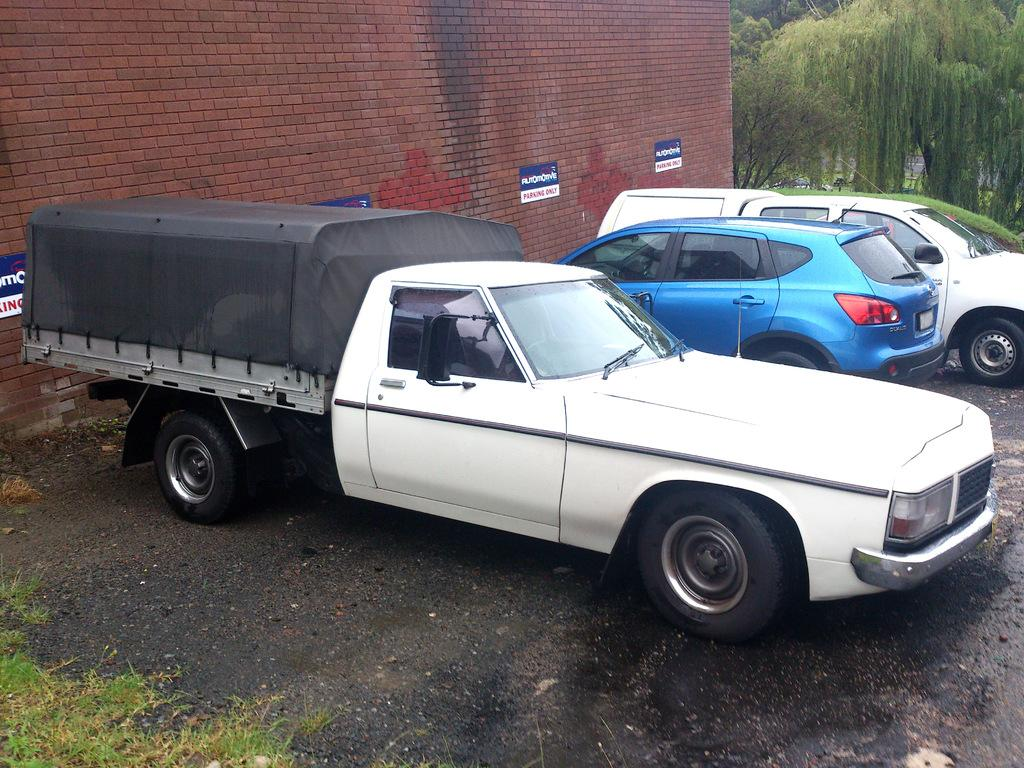What types of objects are present in the image? There are vehicles in the image. Can you describe the appearance of the vehicles? The vehicles are in different colors. What can be seen in the background of the image? There is a wall, banners, trees, grass, and other objects in the background of the image. What type of coil is being used by the representative in the image? There is no representative or coil present in the image. 